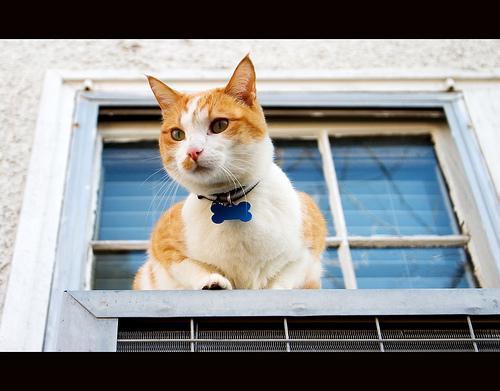How many cats are there?
Give a very brief answer. 1. 